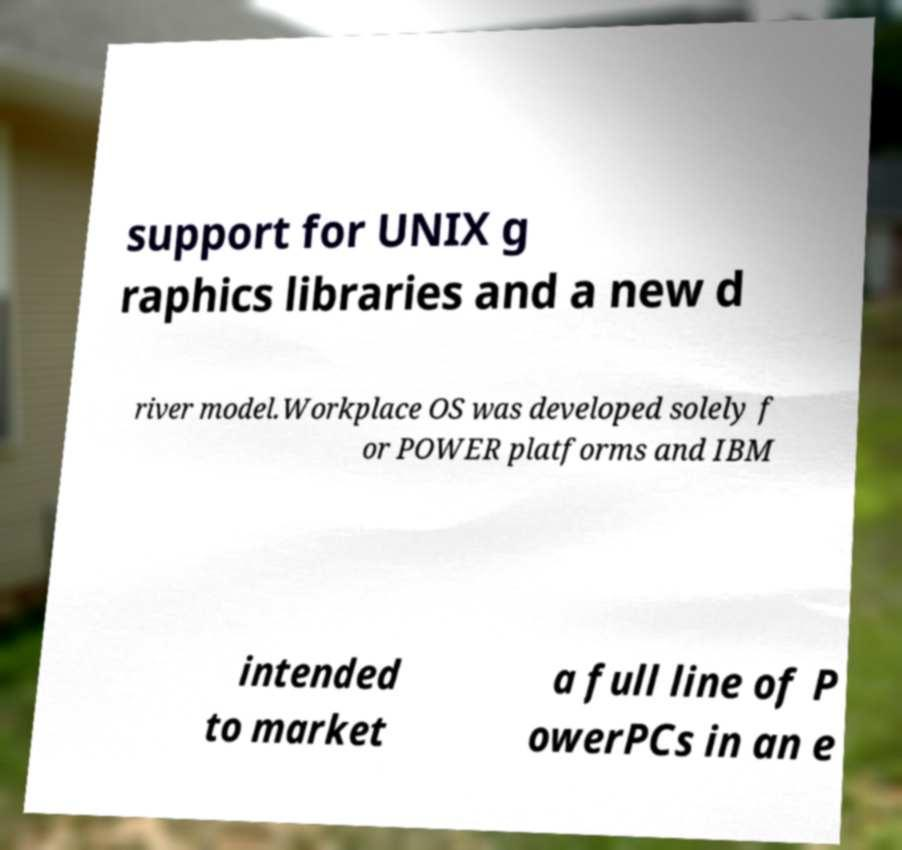Please read and relay the text visible in this image. What does it say? support for UNIX g raphics libraries and a new d river model.Workplace OS was developed solely f or POWER platforms and IBM intended to market a full line of P owerPCs in an e 